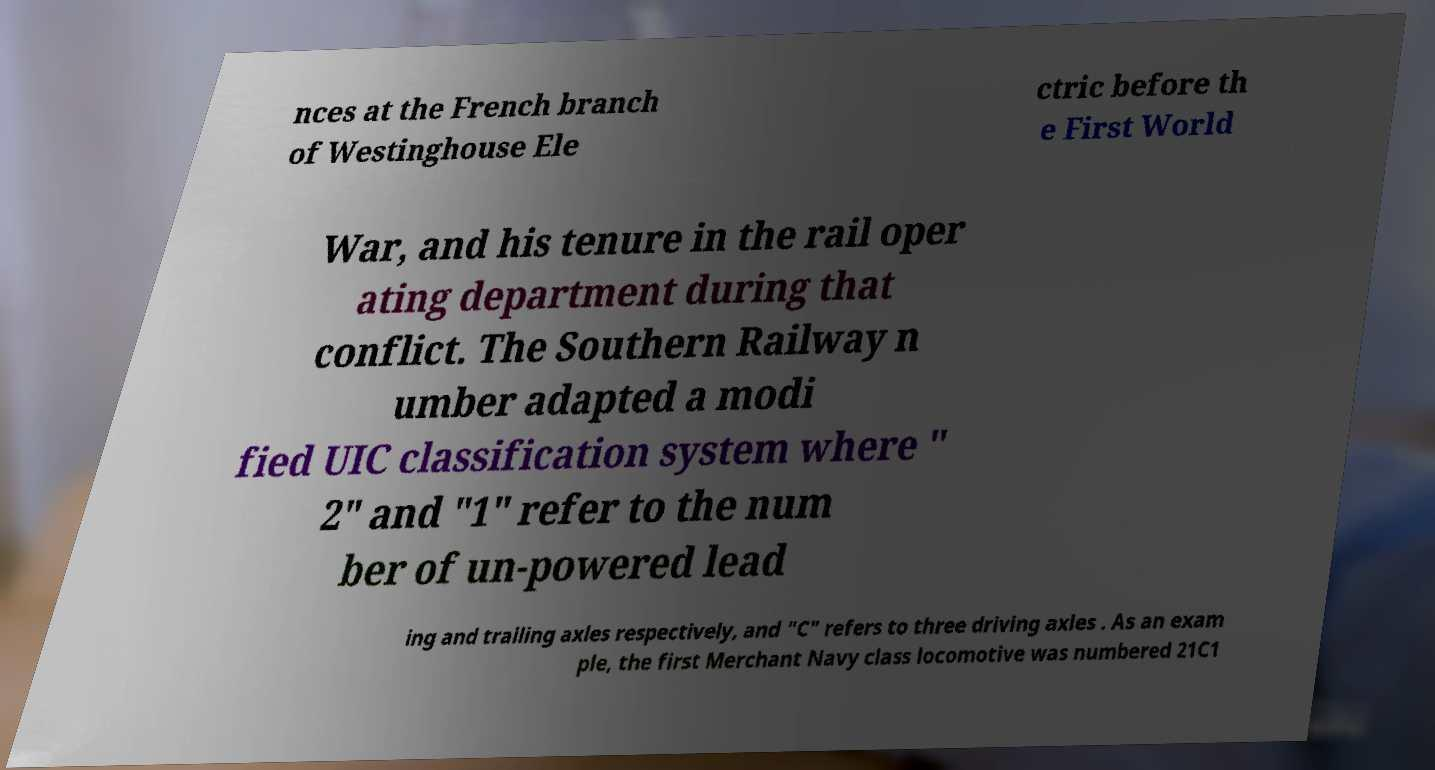Could you extract and type out the text from this image? nces at the French branch of Westinghouse Ele ctric before th e First World War, and his tenure in the rail oper ating department during that conflict. The Southern Railway n umber adapted a modi fied UIC classification system where " 2" and "1" refer to the num ber of un-powered lead ing and trailing axles respectively, and "C" refers to three driving axles . As an exam ple, the first Merchant Navy class locomotive was numbered 21C1 